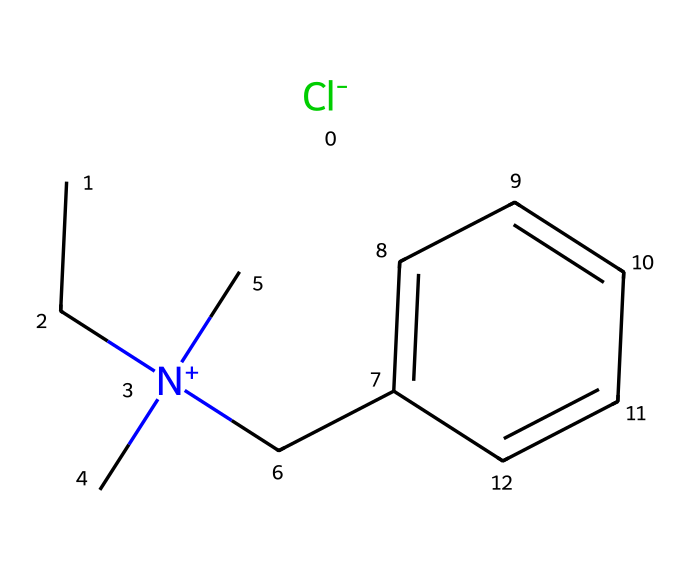What is the primary functional group present in benzalkonium chloride? The structure includes a quaternary ammonium group, which is characterized by a nitrogen atom bonded to four alkyl groups, which is indicative of the functional role of the compound as a surfactant.
Answer: quaternary ammonium How many carbon atoms are present in benzalkonium chloride? By analyzing the SMILES representation, we can count the carbon atoms. There are a total of 11 carbon atoms in the structure, including those in the aromatic ring and the aliphatic chain.
Answer: 11 What is the molecular formula for benzalkonium chloride? To derive the molecular formula from the SMILES, count all atoms: 11 carbons (C), 16 hydrogens (H), 1 nitrogen (N), and 1 chlorine (Cl), leading to the final formula C11H16ClN.
Answer: C11H16ClN How does the molecular structure contribute to its surfactant properties? The long carbon chain provides hydrophobic characteristics, while the quaternary ammonium nitrogen contributes to the hydrophilic part of the molecule, allowing it to interact with both water and oils, essential for a surfactant's efficacy.
Answer: hydrophobic and hydrophilic components What type of bonding is prevalent in benzalkonium chloride? This molecule features ionic bonding due to the positively charged nitrogen and the negatively charged chloride ion, as well as covalent bonds connecting the carbon and nitrogen atoms, which are crucial for its structural integrity.
Answer: ionic and covalent How does the presence of the chlorine atom affect the effectiveness of benzalkonium chloride as a disinfectant? The chlorine atom acts as a counterion which enhances the solubility of the quaternary ammonium compound in water, increasing its efficacy as a disinfectant by allowing it to disperse effectively in various solutions.
Answer: enhances solubility 